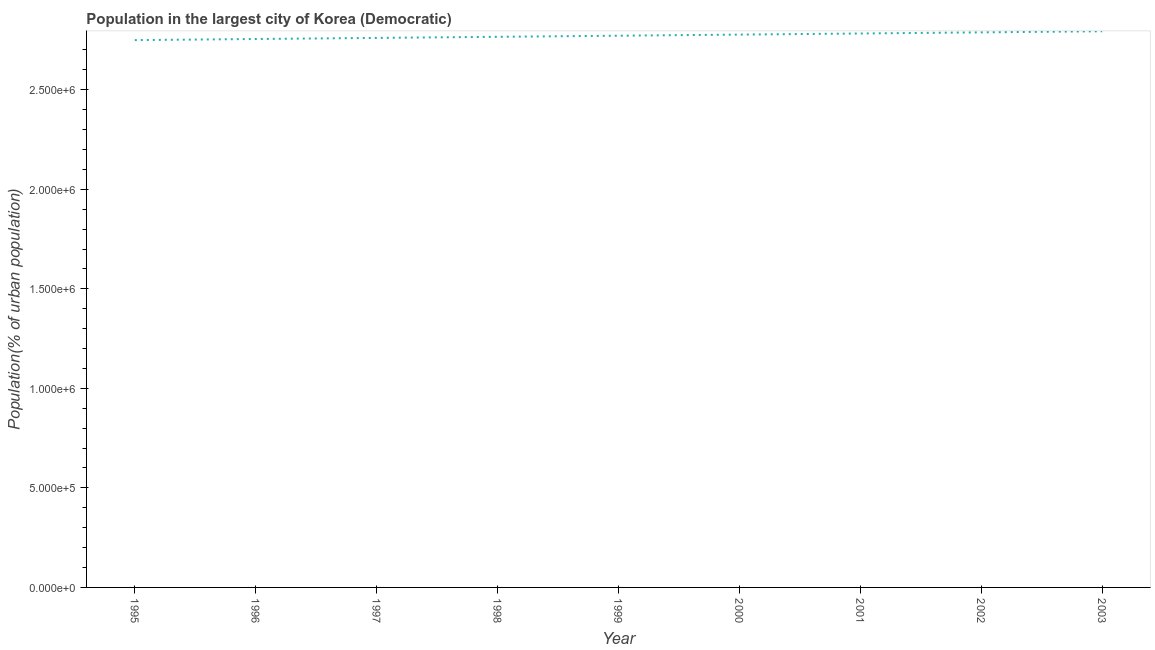What is the population in largest city in 2002?
Ensure brevity in your answer.  2.79e+06. Across all years, what is the maximum population in largest city?
Offer a very short reply. 2.79e+06. Across all years, what is the minimum population in largest city?
Keep it short and to the point. 2.75e+06. In which year was the population in largest city maximum?
Keep it short and to the point. 2003. In which year was the population in largest city minimum?
Offer a terse response. 1995. What is the sum of the population in largest city?
Your answer should be compact. 2.49e+07. What is the difference between the population in largest city in 2001 and 2002?
Give a very brief answer. -5576. What is the average population in largest city per year?
Offer a terse response. 2.77e+06. What is the median population in largest city?
Provide a succinct answer. 2.77e+06. In how many years, is the population in largest city greater than 1000000 %?
Your response must be concise. 9. Do a majority of the years between 1998 and 2001 (inclusive) have population in largest city greater than 2600000 %?
Make the answer very short. Yes. What is the ratio of the population in largest city in 1996 to that in 2001?
Offer a very short reply. 0.99. Is the population in largest city in 1996 less than that in 2000?
Offer a very short reply. Yes. Is the difference between the population in largest city in 1997 and 2001 greater than the difference between any two years?
Provide a succinct answer. No. What is the difference between the highest and the second highest population in largest city?
Your response must be concise. 5587. Is the sum of the population in largest city in 1996 and 1998 greater than the maximum population in largest city across all years?
Provide a short and direct response. Yes. What is the difference between the highest and the lowest population in largest city?
Provide a short and direct response. 4.44e+04. In how many years, is the population in largest city greater than the average population in largest city taken over all years?
Provide a succinct answer. 4. How many lines are there?
Keep it short and to the point. 1. What is the difference between two consecutive major ticks on the Y-axis?
Your response must be concise. 5.00e+05. Are the values on the major ticks of Y-axis written in scientific E-notation?
Your answer should be very brief. Yes. Does the graph contain grids?
Offer a terse response. No. What is the title of the graph?
Your answer should be compact. Population in the largest city of Korea (Democratic). What is the label or title of the Y-axis?
Your response must be concise. Population(% of urban population). What is the Population(% of urban population) of 1995?
Your answer should be very brief. 2.75e+06. What is the Population(% of urban population) of 1996?
Offer a very short reply. 2.76e+06. What is the Population(% of urban population) in 1997?
Provide a short and direct response. 2.76e+06. What is the Population(% of urban population) of 1998?
Offer a very short reply. 2.77e+06. What is the Population(% of urban population) in 1999?
Your answer should be very brief. 2.77e+06. What is the Population(% of urban population) in 2000?
Provide a short and direct response. 2.78e+06. What is the Population(% of urban population) in 2001?
Keep it short and to the point. 2.78e+06. What is the Population(% of urban population) in 2002?
Your answer should be compact. 2.79e+06. What is the Population(% of urban population) of 2003?
Your response must be concise. 2.79e+06. What is the difference between the Population(% of urban population) in 1995 and 1996?
Your answer should be very brief. -5517. What is the difference between the Population(% of urban population) in 1995 and 1997?
Offer a terse response. -1.10e+04. What is the difference between the Population(% of urban population) in 1995 and 1998?
Provide a succinct answer. -1.66e+04. What is the difference between the Population(% of urban population) in 1995 and 1999?
Offer a terse response. -2.21e+04. What is the difference between the Population(% of urban population) in 1995 and 2000?
Make the answer very short. -2.77e+04. What is the difference between the Population(% of urban population) in 1995 and 2001?
Your response must be concise. -3.32e+04. What is the difference between the Population(% of urban population) in 1995 and 2002?
Keep it short and to the point. -3.88e+04. What is the difference between the Population(% of urban population) in 1995 and 2003?
Provide a short and direct response. -4.44e+04. What is the difference between the Population(% of urban population) in 1996 and 1997?
Offer a very short reply. -5513. What is the difference between the Population(% of urban population) in 1996 and 1998?
Your answer should be very brief. -1.10e+04. What is the difference between the Population(% of urban population) in 1996 and 1999?
Offer a terse response. -1.66e+04. What is the difference between the Population(% of urban population) in 1996 and 2000?
Offer a terse response. -2.21e+04. What is the difference between the Population(% of urban population) in 1996 and 2001?
Give a very brief answer. -2.77e+04. What is the difference between the Population(% of urban population) in 1996 and 2002?
Your answer should be very brief. -3.33e+04. What is the difference between the Population(% of urban population) in 1996 and 2003?
Your answer should be very brief. -3.89e+04. What is the difference between the Population(% of urban population) in 1997 and 1998?
Offer a very short reply. -5531. What is the difference between the Population(% of urban population) in 1997 and 1999?
Offer a very short reply. -1.11e+04. What is the difference between the Population(% of urban population) in 1997 and 2000?
Give a very brief answer. -1.66e+04. What is the difference between the Population(% of urban population) in 1997 and 2001?
Provide a succinct answer. -2.22e+04. What is the difference between the Population(% of urban population) in 1997 and 2002?
Ensure brevity in your answer.  -2.78e+04. What is the difference between the Population(% of urban population) in 1997 and 2003?
Offer a very short reply. -3.34e+04. What is the difference between the Population(% of urban population) in 1998 and 1999?
Give a very brief answer. -5543. What is the difference between the Population(% of urban population) in 1998 and 2000?
Make the answer very short. -1.11e+04. What is the difference between the Population(% of urban population) in 1998 and 2001?
Provide a succinct answer. -1.67e+04. What is the difference between the Population(% of urban population) in 1998 and 2002?
Make the answer very short. -2.22e+04. What is the difference between the Population(% of urban population) in 1998 and 2003?
Provide a succinct answer. -2.78e+04. What is the difference between the Population(% of urban population) in 1999 and 2000?
Provide a succinct answer. -5561. What is the difference between the Population(% of urban population) in 1999 and 2001?
Your answer should be compact. -1.11e+04. What is the difference between the Population(% of urban population) in 1999 and 2002?
Keep it short and to the point. -1.67e+04. What is the difference between the Population(% of urban population) in 1999 and 2003?
Offer a terse response. -2.23e+04. What is the difference between the Population(% of urban population) in 2000 and 2001?
Make the answer very short. -5558. What is the difference between the Population(% of urban population) in 2000 and 2002?
Provide a short and direct response. -1.11e+04. What is the difference between the Population(% of urban population) in 2000 and 2003?
Your response must be concise. -1.67e+04. What is the difference between the Population(% of urban population) in 2001 and 2002?
Ensure brevity in your answer.  -5576. What is the difference between the Population(% of urban population) in 2001 and 2003?
Offer a terse response. -1.12e+04. What is the difference between the Population(% of urban population) in 2002 and 2003?
Your response must be concise. -5587. What is the ratio of the Population(% of urban population) in 1995 to that in 1997?
Provide a succinct answer. 1. What is the ratio of the Population(% of urban population) in 1995 to that in 1998?
Provide a succinct answer. 0.99. What is the ratio of the Population(% of urban population) in 1995 to that in 2002?
Ensure brevity in your answer.  0.99. What is the ratio of the Population(% of urban population) in 1995 to that in 2003?
Your response must be concise. 0.98. What is the ratio of the Population(% of urban population) in 1996 to that in 1998?
Your answer should be very brief. 1. What is the ratio of the Population(% of urban population) in 1996 to that in 1999?
Give a very brief answer. 0.99. What is the ratio of the Population(% of urban population) in 1996 to that in 2001?
Offer a very short reply. 0.99. What is the ratio of the Population(% of urban population) in 1996 to that in 2003?
Your response must be concise. 0.99. What is the ratio of the Population(% of urban population) in 1997 to that in 1999?
Your answer should be compact. 1. What is the ratio of the Population(% of urban population) in 1997 to that in 2000?
Ensure brevity in your answer.  0.99. What is the ratio of the Population(% of urban population) in 1998 to that in 1999?
Offer a very short reply. 1. What is the ratio of the Population(% of urban population) in 1998 to that in 2000?
Your answer should be very brief. 1. What is the ratio of the Population(% of urban population) in 1998 to that in 2001?
Give a very brief answer. 0.99. What is the ratio of the Population(% of urban population) in 1998 to that in 2002?
Your response must be concise. 0.99. What is the ratio of the Population(% of urban population) in 1998 to that in 2003?
Your answer should be compact. 0.99. What is the ratio of the Population(% of urban population) in 1999 to that in 2002?
Keep it short and to the point. 0.99. What is the ratio of the Population(% of urban population) in 1999 to that in 2003?
Offer a very short reply. 0.99. What is the ratio of the Population(% of urban population) in 2000 to that in 2001?
Provide a short and direct response. 1. What is the ratio of the Population(% of urban population) in 2001 to that in 2002?
Your answer should be very brief. 1. 